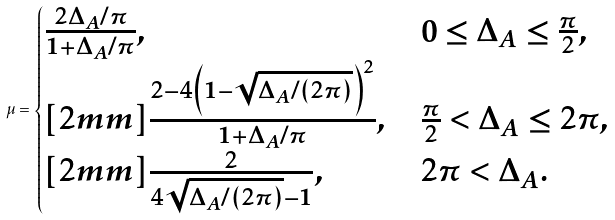<formula> <loc_0><loc_0><loc_500><loc_500>\mu = \begin{cases} \frac { 2 \Delta _ { A } / \pi } { 1 + \Delta _ { A } / \pi } , & 0 \leq \Delta _ { A } \leq \frac { \pi } { 2 } , \\ [ 2 m m ] \frac { 2 - 4 \left ( 1 - \sqrt { \Delta _ { A } / ( 2 \pi ) } \right ) ^ { 2 } } { 1 + \Delta _ { A } / \pi } , & \frac { \pi } { 2 } < \Delta _ { A } \leq 2 \pi , \\ [ 2 m m ] \frac { 2 } { 4 \sqrt { \Delta _ { A } / ( 2 \pi ) } - 1 } , & 2 \pi < \Delta _ { A } . \end{cases}</formula> 